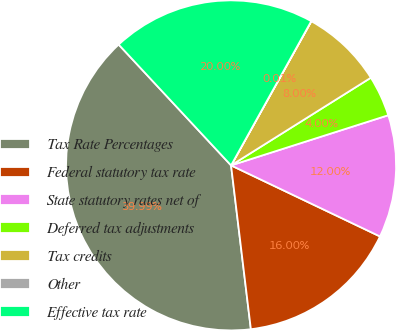Convert chart to OTSL. <chart><loc_0><loc_0><loc_500><loc_500><pie_chart><fcel>Tax Rate Percentages<fcel>Federal statutory tax rate<fcel>State statutory rates net of<fcel>Deferred tax adjustments<fcel>Tax credits<fcel>Other<fcel>Effective tax rate<nl><fcel>39.99%<fcel>16.0%<fcel>12.0%<fcel>4.0%<fcel>8.0%<fcel>0.01%<fcel>20.0%<nl></chart> 